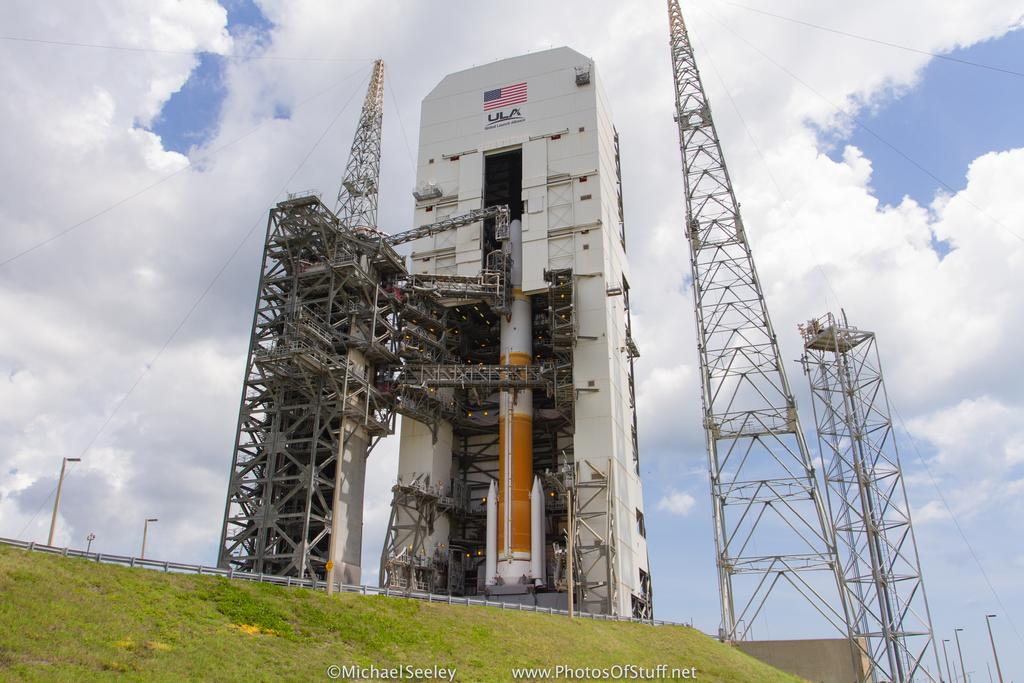<image>
Offer a succinct explanation of the picture presented. Giant structure outdoors with an American flag and the word ULA on it. 